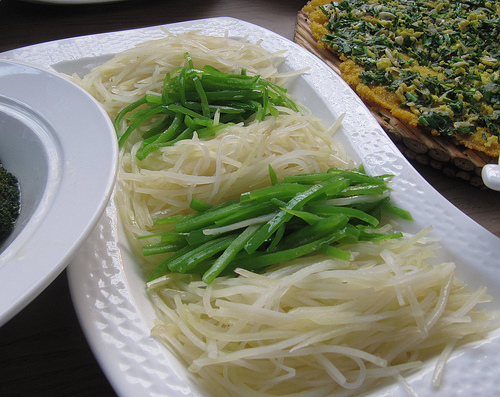<image>
Is there a plate on the vegetables? No. The plate is not positioned on the vegetables. They may be near each other, but the plate is not supported by or resting on top of the vegetables. Is there a food next to the plate? Yes. The food is positioned adjacent to the plate, located nearby in the same general area. 